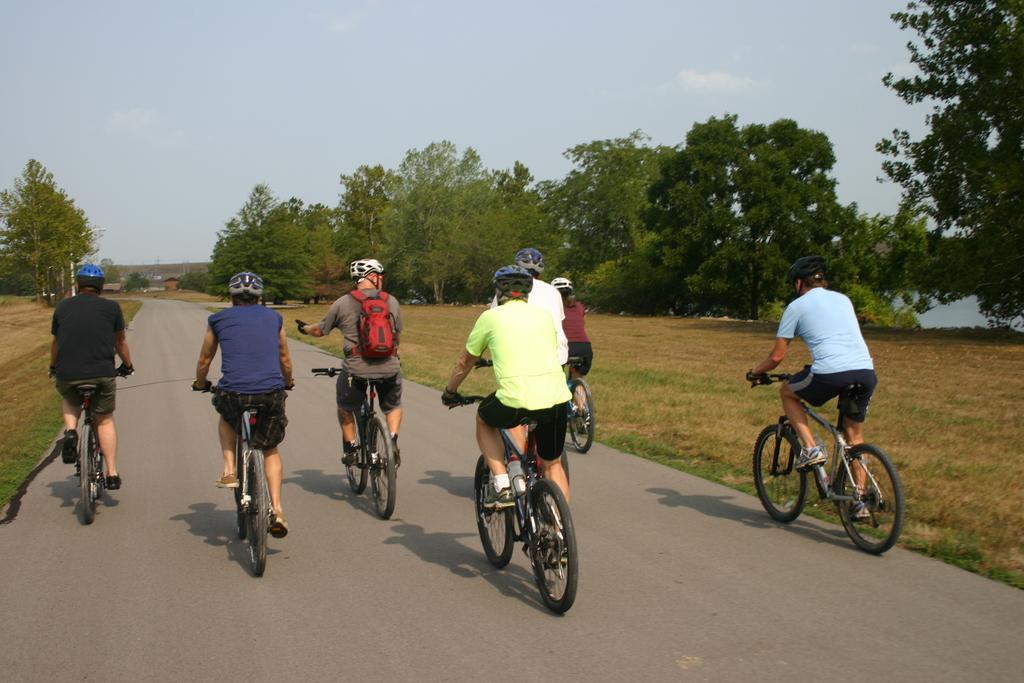Could you give a brief overview of what you see in this image? In this image In the middle there are seven people riding bicycle they wear helmets. In the middle there is a man he wear t shirt, trouser, backpack and helmet he is riding bicycle. In the background there is a road, trees, grass, sky, clouds. 